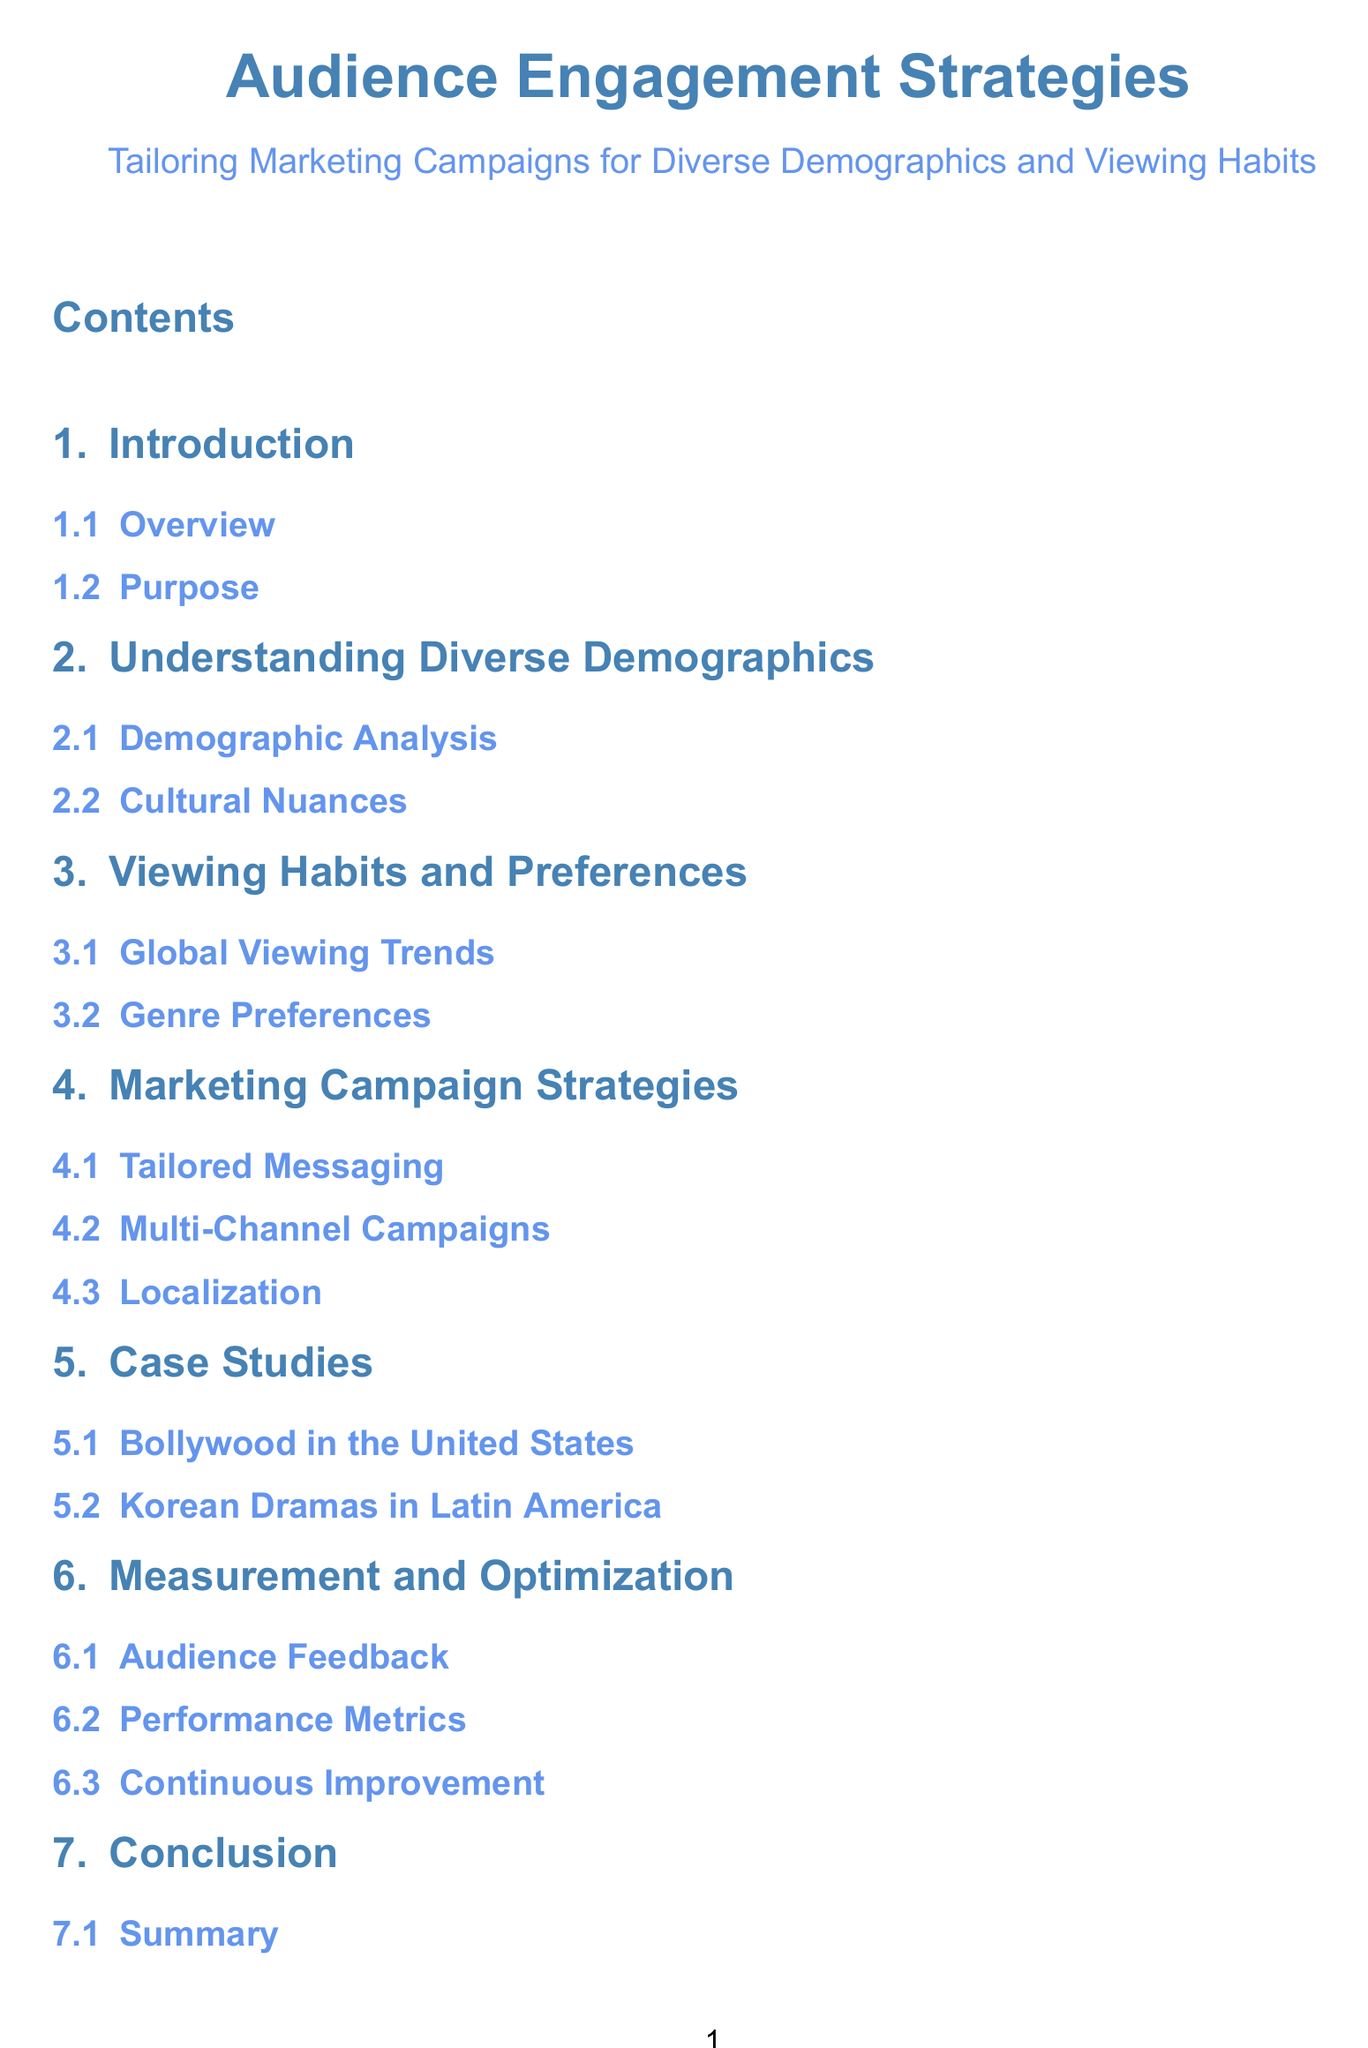What is the title of the document? The title of the document is the main heading shown in the table of contents.
Answer: Audience Engagement Strategies What is the subtitle of the document? The subtitle provides additional context and is found immediately under the main title.
Answer: Tailoring Marketing Campaigns for Diverse Demographics and Viewing Habits How many main sections are listed in the table of contents? The number of main sections includes the Introduction, Understanding Diverse Demographics, Viewing Habits and Preferences, Marketing Campaign Strategies, Case Studies, Measurement and Optimization, Conclusion, and References.
Answer: 8 What is the first subsection under the Introduction? The first subsection presents an overview of the introductory section.
Answer: Overview What is a case study mentioned in the document? This refers to specific examples provided in the Case Studies section, detailing success stories of engagement strategies.
Answer: Bollywood in the United States What is the focus of the section titled "Measurement and Optimization"? This section emphasizes methods for assessing and improving audience engagement strategies.
Answer: Audience Feedback Which international market is explored in the Case Studies? This refers to foreign film markets discussed within the Case Studies section.
Answer: Latin America What type of campaigns are emphasized in the Marketing Campaign Strategies section? This question examines the specific approach highlighted for reaching diverse audiences through marketing.
Answer: Multi-Channel Campaigns 